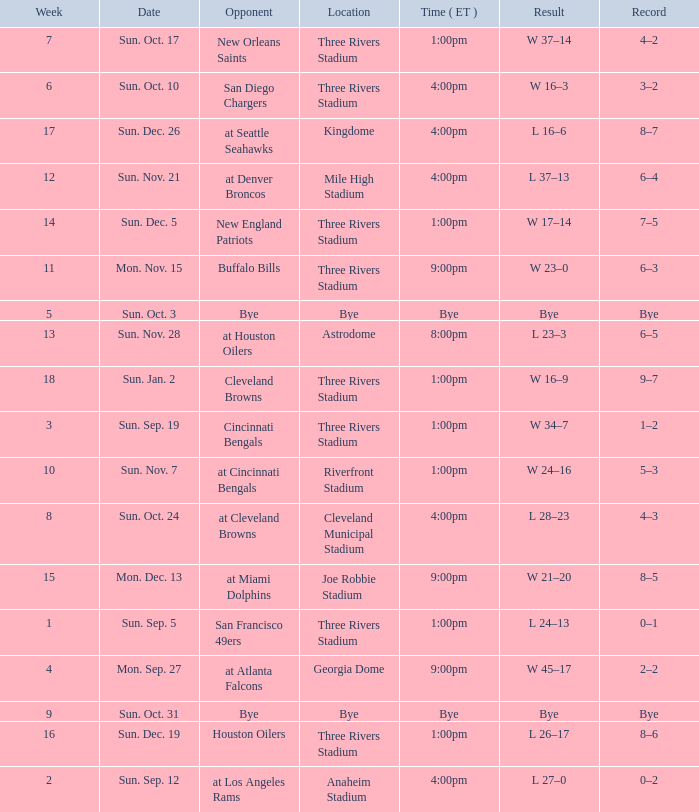What week that shows a game record of 0–1? 1.0. 